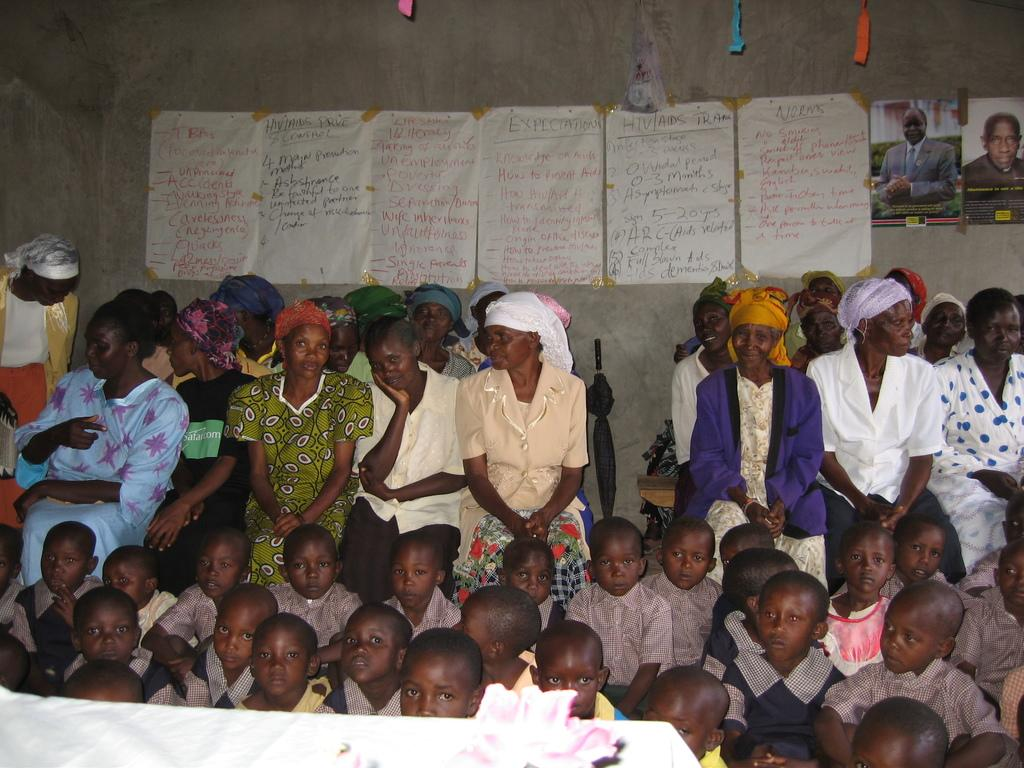What is the main subject of the image? The main subject of the image is a group of people. Can you describe the composition of the group? There are children in the group, along with other people. Where are the people and children located in the image? They are sitting in the center of the image. What can be seen on the wall in the center of the image? There are posters on the wall in the center of the image. What type of dinner is being served in the image? There is no dinner present in the image; it features a group of people sitting in the center with posters on the wall. Can you see a monkey interacting with the children in the image? There is no monkey present in the image. 